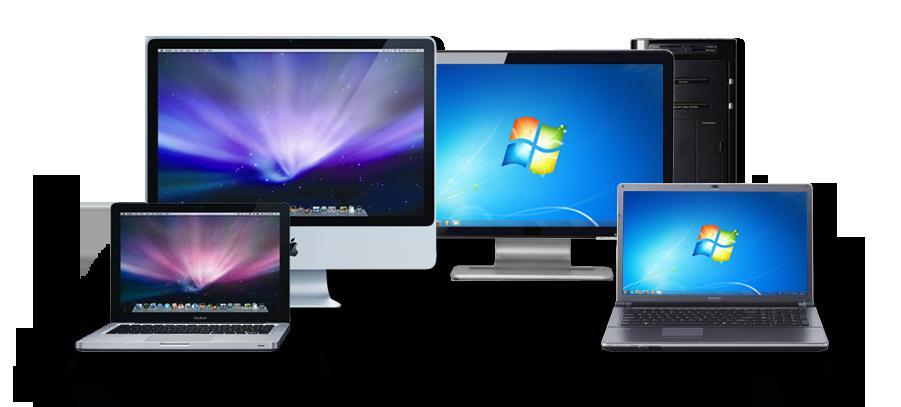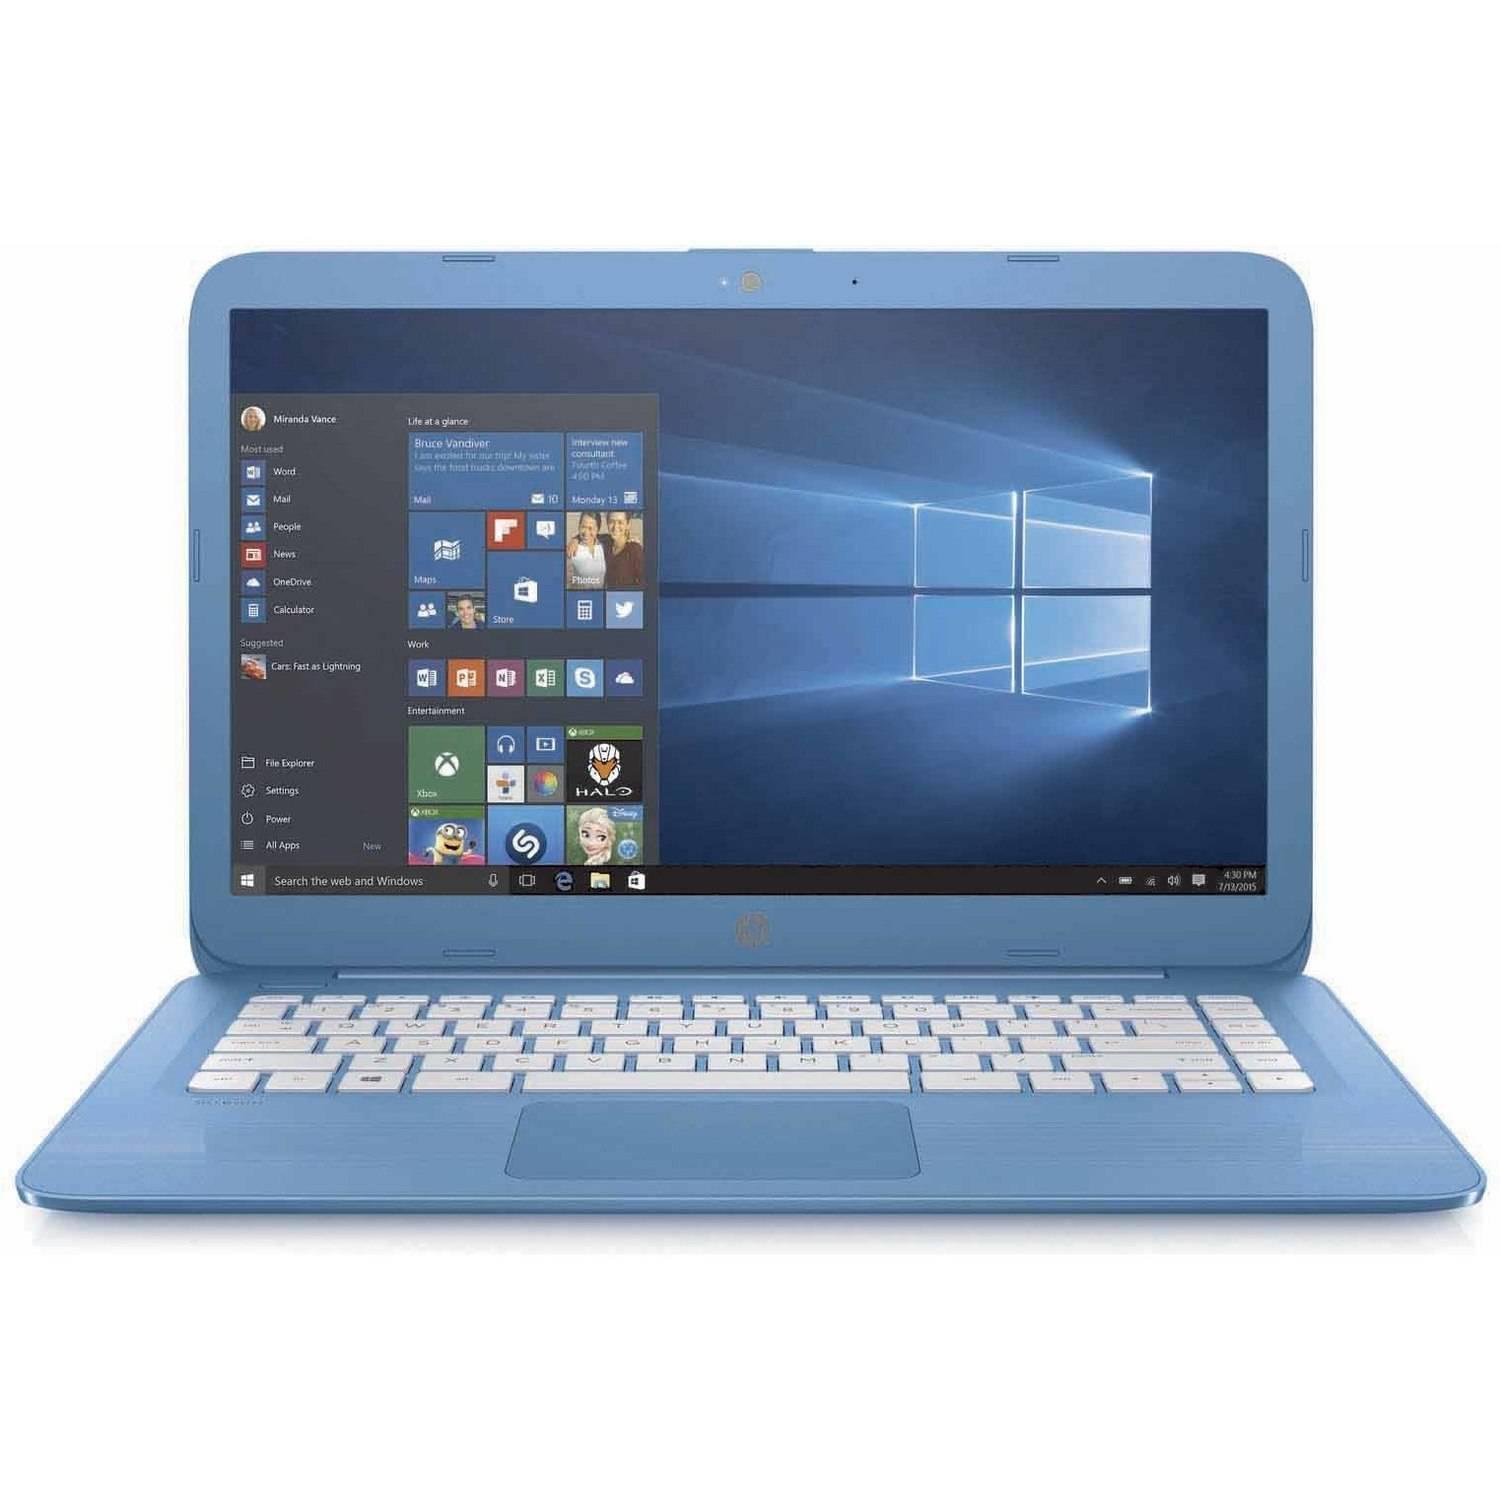The first image is the image on the left, the second image is the image on the right. Evaluate the accuracy of this statement regarding the images: "The left and right image contains the same number of two in one laptops.". Is it true? Answer yes or no. No. The first image is the image on the left, the second image is the image on the right. Analyze the images presented: Is the assertion "There is one computer in each image." valid? Answer yes or no. No. 